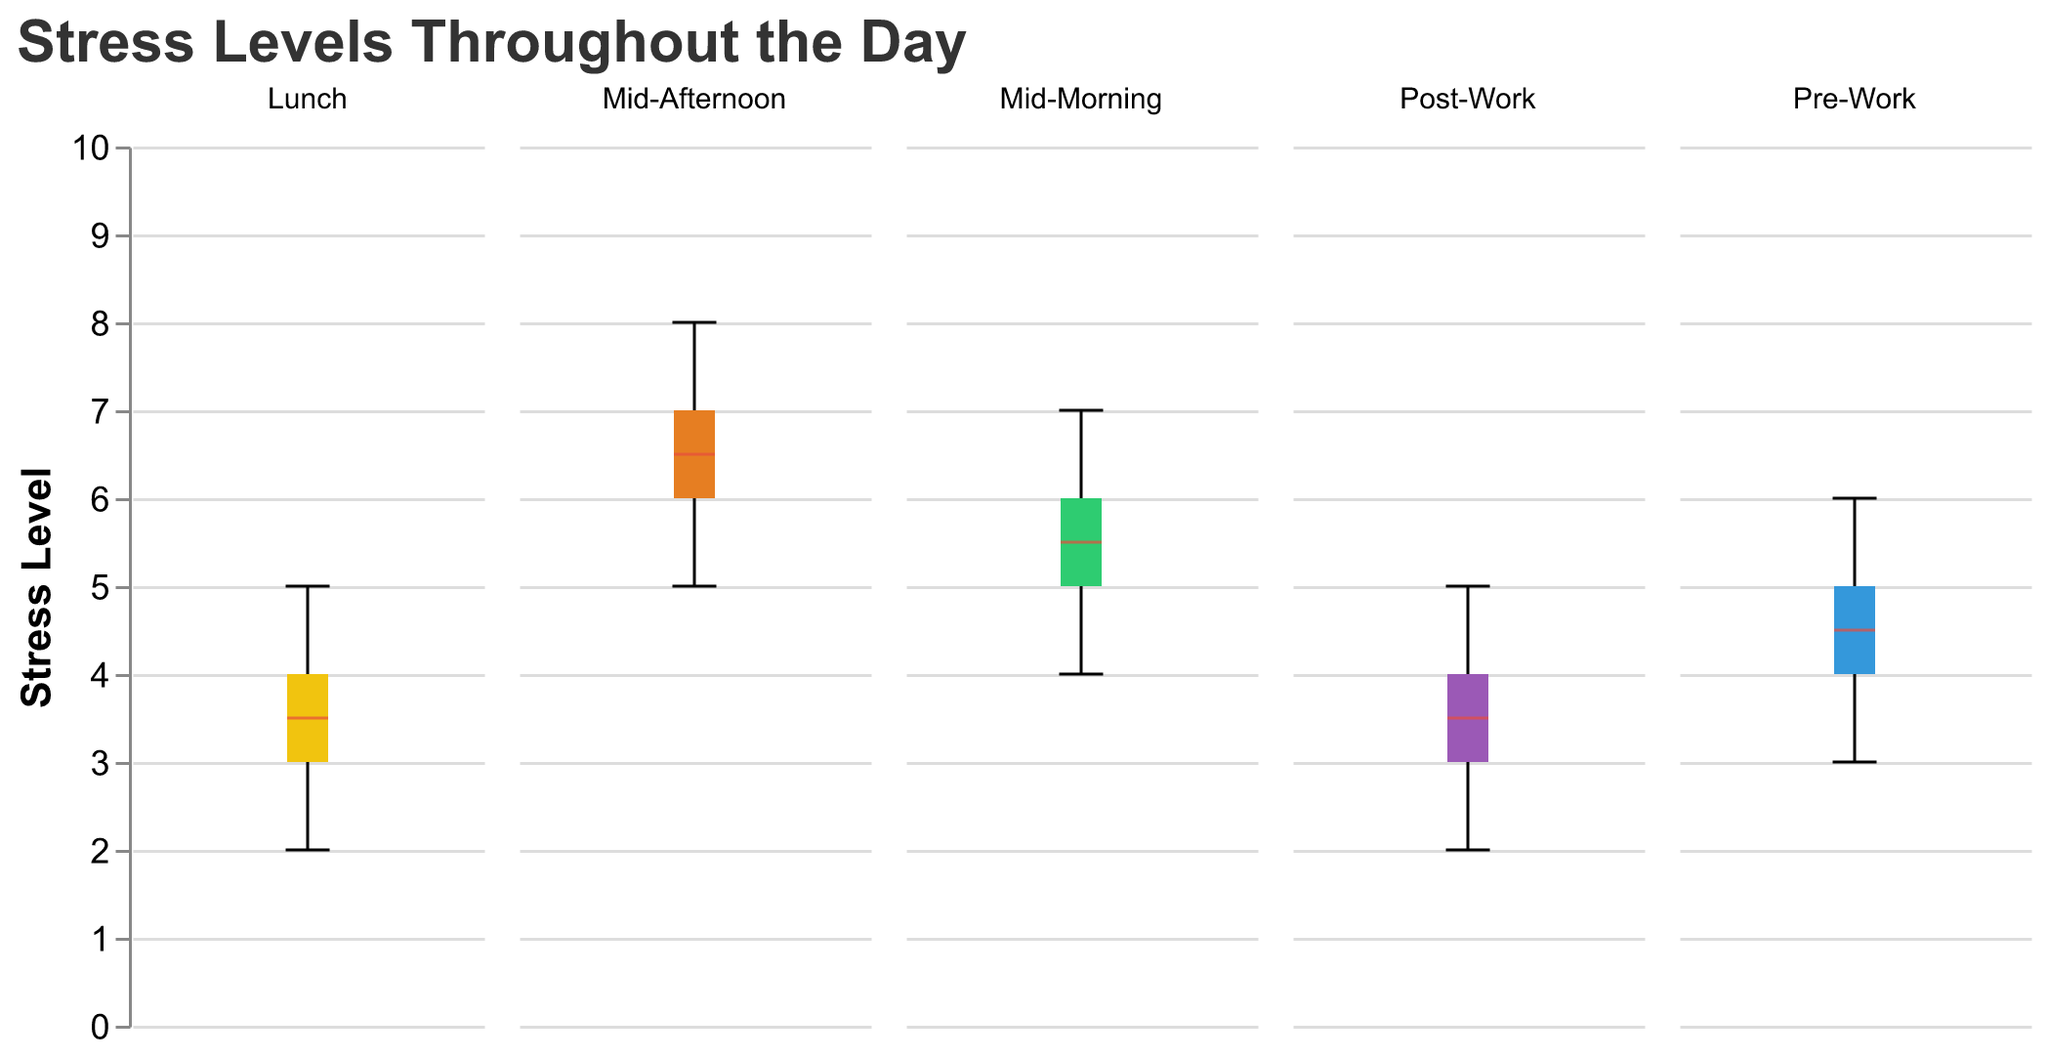What is the title of the figure? The title is displayed at the top of the figure, usually in a larger font size and bold formatting to distinguish it from other text. In this case, it is "Stress Levels Throughout the Day."
Answer: Stress Levels Throughout the Day Which time of the day shows the highest median stress level? Looking at the box plots, the median value for each time segment can be observed as a line inside the box. Identify the segment with the highest median line.
Answer: Mid-Afternoon How many subjects have their stress levels recorded in the dataset? Each box plot shows data points for each subject. Count the data points shown in any of the box plots to determine the total number of subjects.
Answer: 10 Which time of the day exhibited the widest range of stress levels? The range of stress levels can be evaluated by looking at the length of the whiskers (the lines extending from the top and bottom of the box). The longest whiskers indicate the widest range.
Answer: Mid-Afternoon Compare the median stress level between Pre-Work and Post-Work. Which one is higher? Compare the median lines in the box plots for the "Pre-Work" and "Post-Work" time segments. The median is the central line in each box.
Answer: Pre-Work What times of the day show a median stress level of 3? Identify the central line in each box plot and look for those that align with the 3 on the y-axis.
Answer: Lunch, Post-Work Which time of the day shows the least variance in stress levels? The smallest box and the shortest whiskers indicate the smallest variance. Look for the box with the smallest height and shortest whiskers.
Answer: Lunch How do stress levels change from Mid-Morning to Mid-Afternoon? Observe the median lines and general distribution (spread) of the box plots for "Mid-Morning" and "Mid-Afternoon." Compare differences in central tendency and range.
Answer: They increase Which time period has outliers and how are they represented? Outliers in box plots are shown as individual points outside the whiskers. Look for any such points in each subplot and identify the corresponding time period.
Answer: None What is the color used for the Lunch time segment in the box plots? Each time segment is color-coded differently. The color for the "Lunch" time segment can be identified by observing the corresponding box plot.
Answer: Yellow 